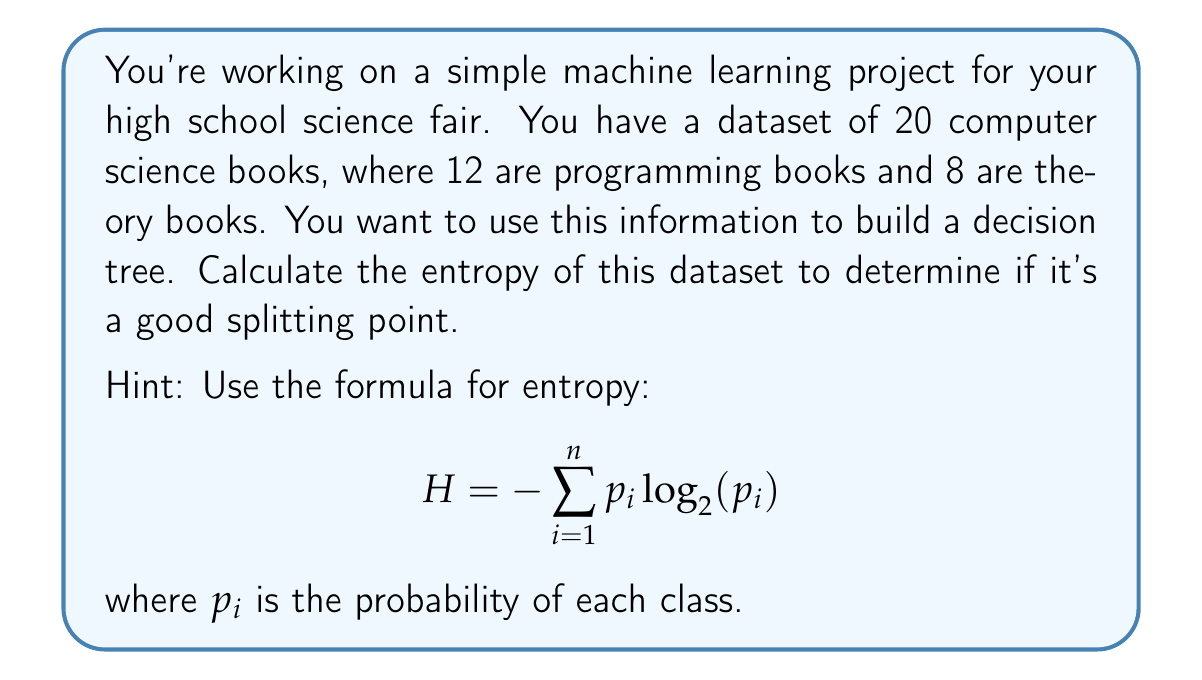Can you answer this question? Let's approach this step-by-step:

1) We have two classes: programming books and theory books.

2) Calculate the probabilities:
   - P(programming) = 12/20 = 0.6
   - P(theory) = 8/20 = 0.4

3) Now, let's apply the entropy formula:
   $$H = -[p(\text{programming}) \log_2(p(\text{programming})) + p(\text{theory}) \log_2(p(\text{theory}))]$$

4) Substitute the values:
   $$H = -[0.6 \log_2(0.6) + 0.4 \log_2(0.4)]$$

5) Calculate:
   $$\begin{align}
   H &= -[0.6 \cdot (-0.737) + 0.4 \cdot (-1.322)] \\
   &= -[-0.442 - 0.529] \\
   &= 0.971
   \end{align}$$

The entropy is approximately 0.971 bits.

Note: A high entropy (close to 1) indicates a more even distribution, suggesting this could be a good splitting point for the decision tree.
Answer: 0.971 bits 